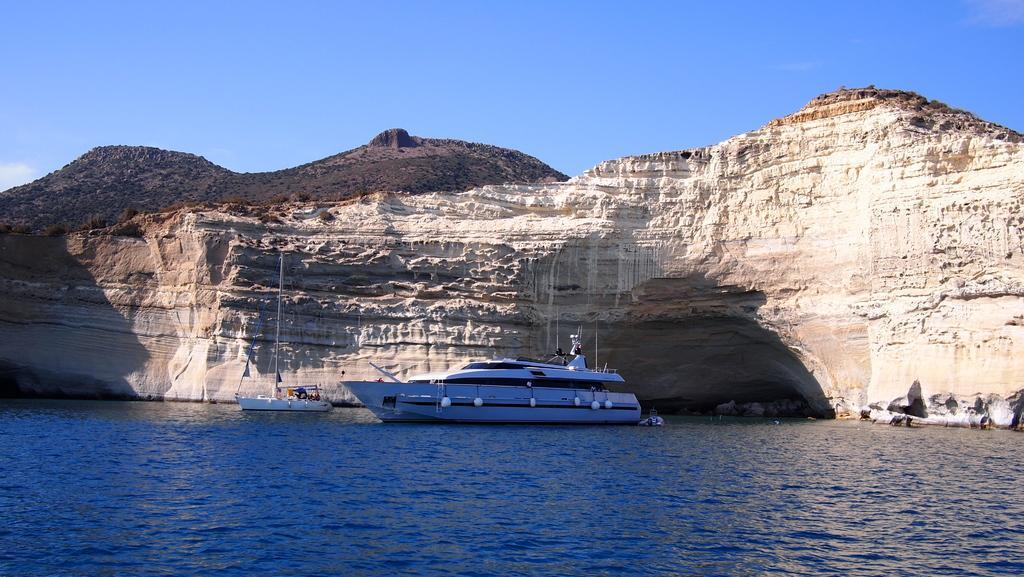Describe this image in one or two sentences. There is one ship, and a boat is on the surface of water at the bottom of this image, and there is a mountain in the background, and there is a blue sky at the top of this image. 